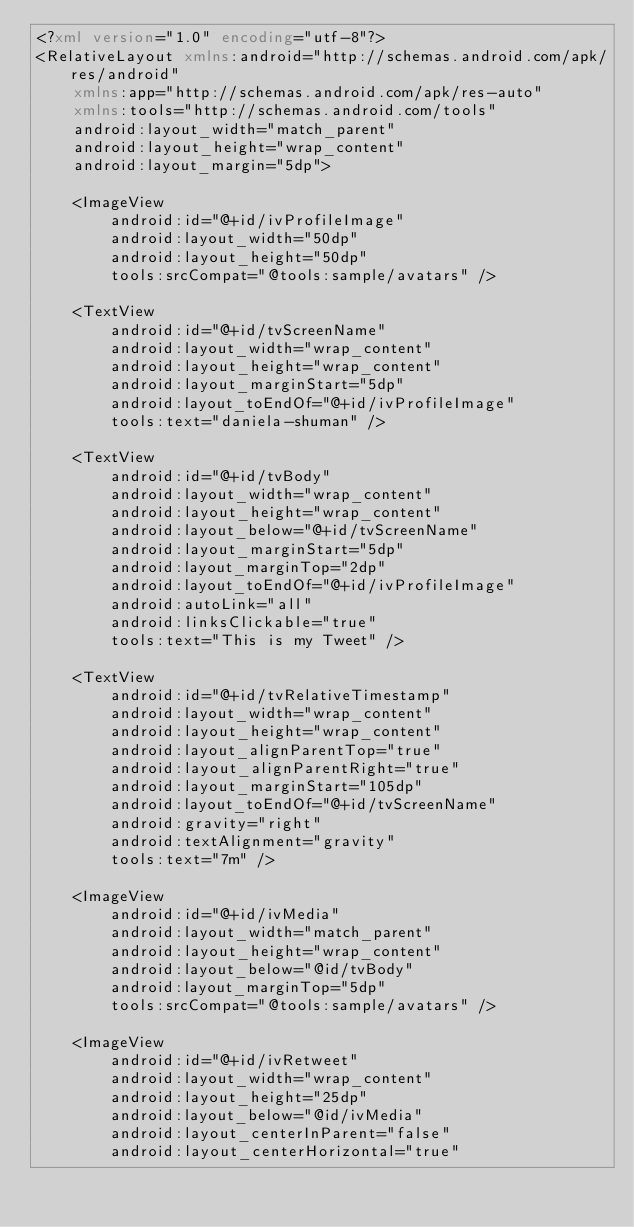Convert code to text. <code><loc_0><loc_0><loc_500><loc_500><_XML_><?xml version="1.0" encoding="utf-8"?>
<RelativeLayout xmlns:android="http://schemas.android.com/apk/res/android"
    xmlns:app="http://schemas.android.com/apk/res-auto"
    xmlns:tools="http://schemas.android.com/tools"
    android:layout_width="match_parent"
    android:layout_height="wrap_content"
    android:layout_margin="5dp">

    <ImageView
        android:id="@+id/ivProfileImage"
        android:layout_width="50dp"
        android:layout_height="50dp"
        tools:srcCompat="@tools:sample/avatars" />

    <TextView
        android:id="@+id/tvScreenName"
        android:layout_width="wrap_content"
        android:layout_height="wrap_content"
        android:layout_marginStart="5dp"
        android:layout_toEndOf="@+id/ivProfileImage"
        tools:text="daniela-shuman" />

    <TextView
        android:id="@+id/tvBody"
        android:layout_width="wrap_content"
        android:layout_height="wrap_content"
        android:layout_below="@+id/tvScreenName"
        android:layout_marginStart="5dp"
        android:layout_marginTop="2dp"
        android:layout_toEndOf="@+id/ivProfileImage"
        android:autoLink="all"
        android:linksClickable="true"
        tools:text="This is my Tweet" />

    <TextView
        android:id="@+id/tvRelativeTimestamp"
        android:layout_width="wrap_content"
        android:layout_height="wrap_content"
        android:layout_alignParentTop="true"
        android:layout_alignParentRight="true"
        android:layout_marginStart="105dp"
        android:layout_toEndOf="@+id/tvScreenName"
        android:gravity="right"
        android:textAlignment="gravity"
        tools:text="7m" />

    <ImageView
        android:id="@+id/ivMedia"
        android:layout_width="match_parent"
        android:layout_height="wrap_content"
        android:layout_below="@id/tvBody"
        android:layout_marginTop="5dp"
        tools:srcCompat="@tools:sample/avatars" />

    <ImageView
        android:id="@+id/ivRetweet"
        android:layout_width="wrap_content"
        android:layout_height="25dp"
        android:layout_below="@id/ivMedia"
        android:layout_centerInParent="false"
        android:layout_centerHorizontal="true"</code> 